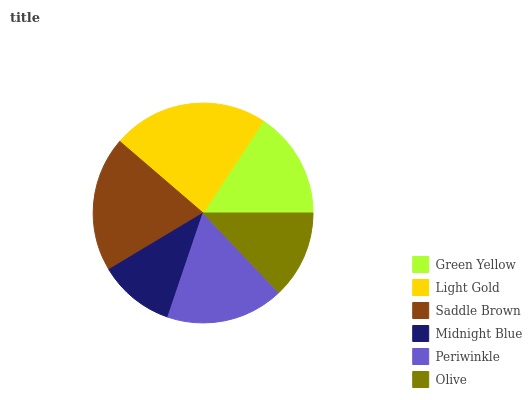Is Midnight Blue the minimum?
Answer yes or no. Yes. Is Light Gold the maximum?
Answer yes or no. Yes. Is Saddle Brown the minimum?
Answer yes or no. No. Is Saddle Brown the maximum?
Answer yes or no. No. Is Light Gold greater than Saddle Brown?
Answer yes or no. Yes. Is Saddle Brown less than Light Gold?
Answer yes or no. Yes. Is Saddle Brown greater than Light Gold?
Answer yes or no. No. Is Light Gold less than Saddle Brown?
Answer yes or no. No. Is Periwinkle the high median?
Answer yes or no. Yes. Is Green Yellow the low median?
Answer yes or no. Yes. Is Green Yellow the high median?
Answer yes or no. No. Is Olive the low median?
Answer yes or no. No. 